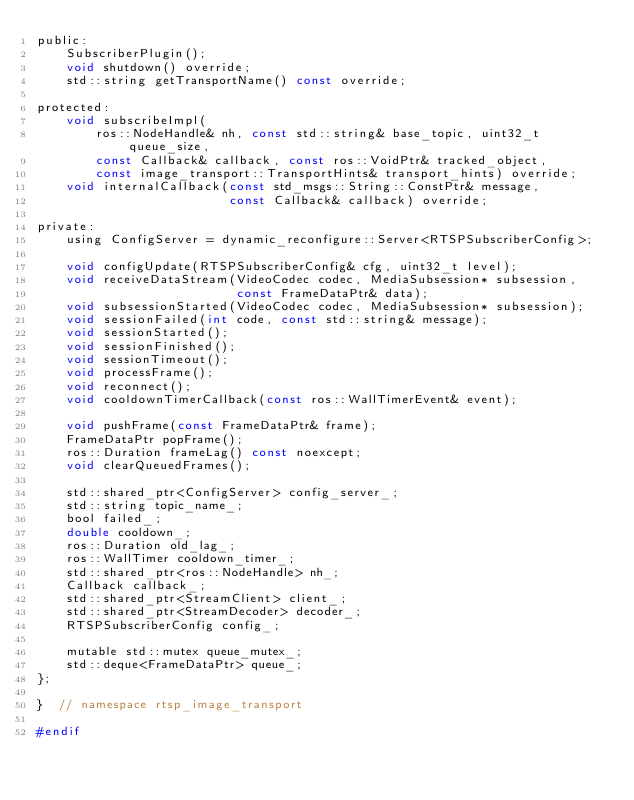<code> <loc_0><loc_0><loc_500><loc_500><_C_>public:
    SubscriberPlugin();
    void shutdown() override;
    std::string getTransportName() const override;

protected:
    void subscribeImpl(
        ros::NodeHandle& nh, const std::string& base_topic, uint32_t queue_size,
        const Callback& callback, const ros::VoidPtr& tracked_object,
        const image_transport::TransportHints& transport_hints) override;
    void internalCallback(const std_msgs::String::ConstPtr& message,
                          const Callback& callback) override;

private:
    using ConfigServer = dynamic_reconfigure::Server<RTSPSubscriberConfig>;

    void configUpdate(RTSPSubscriberConfig& cfg, uint32_t level);
    void receiveDataStream(VideoCodec codec, MediaSubsession* subsession,
                           const FrameDataPtr& data);
    void subsessionStarted(VideoCodec codec, MediaSubsession* subsession);
    void sessionFailed(int code, const std::string& message);
    void sessionStarted();
    void sessionFinished();
    void sessionTimeout();
    void processFrame();
    void reconnect();
    void cooldownTimerCallback(const ros::WallTimerEvent& event);

    void pushFrame(const FrameDataPtr& frame);
    FrameDataPtr popFrame();
    ros::Duration frameLag() const noexcept;
    void clearQueuedFrames();

    std::shared_ptr<ConfigServer> config_server_;
    std::string topic_name_;
    bool failed_;
    double cooldown_;
    ros::Duration old_lag_;
    ros::WallTimer cooldown_timer_;
    std::shared_ptr<ros::NodeHandle> nh_;
    Callback callback_;
    std::shared_ptr<StreamClient> client_;
    std::shared_ptr<StreamDecoder> decoder_;
    RTSPSubscriberConfig config_;

    mutable std::mutex queue_mutex_;
    std::deque<FrameDataPtr> queue_;
};

}  // namespace rtsp_image_transport

#endif
</code> 